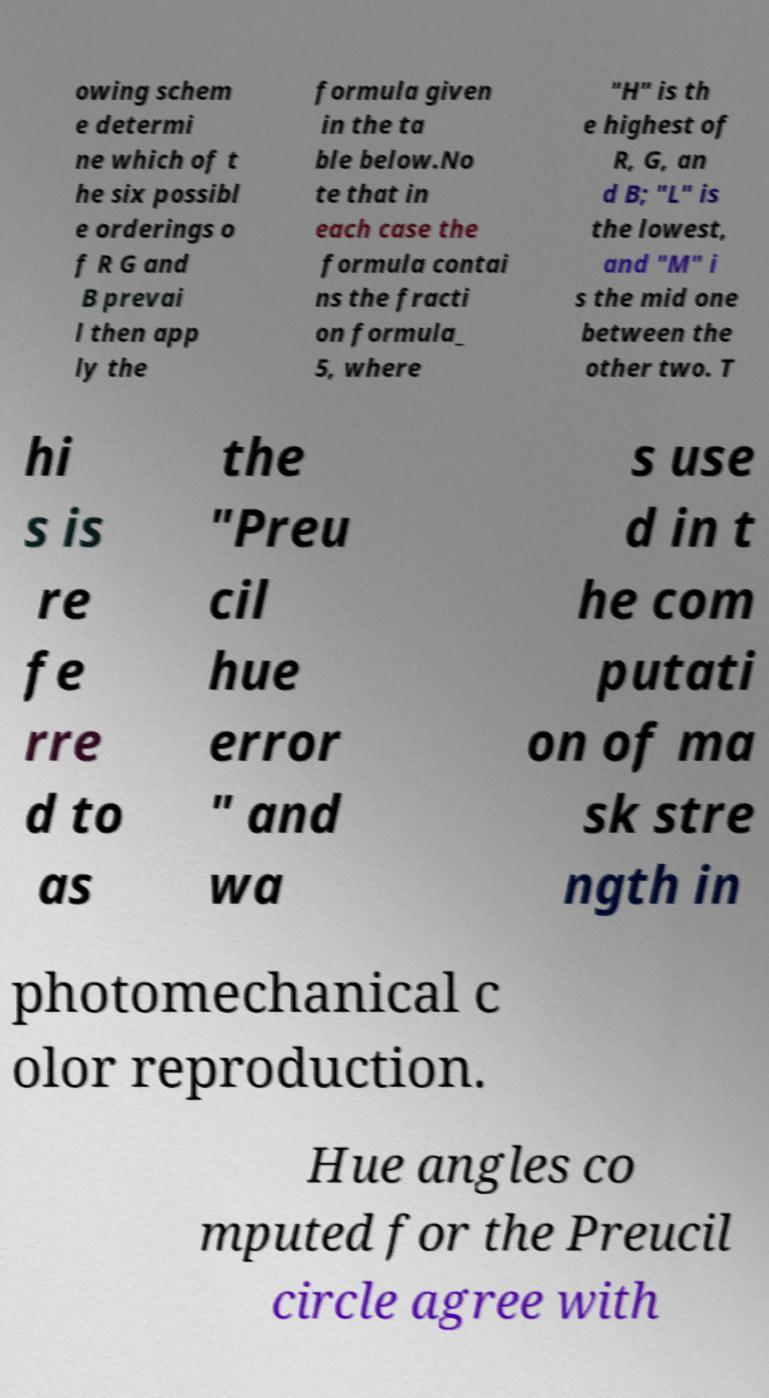Can you read and provide the text displayed in the image?This photo seems to have some interesting text. Can you extract and type it out for me? owing schem e determi ne which of t he six possibl e orderings o f R G and B prevai l then app ly the formula given in the ta ble below.No te that in each case the formula contai ns the fracti on formula_ 5, where "H" is th e highest of R, G, an d B; "L" is the lowest, and "M" i s the mid one between the other two. T hi s is re fe rre d to as the "Preu cil hue error " and wa s use d in t he com putati on of ma sk stre ngth in photomechanical c olor reproduction. Hue angles co mputed for the Preucil circle agree with 